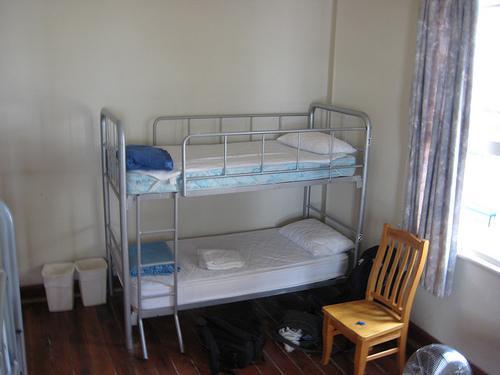How many trash cans are there?
Give a very brief answer. 2. How many beds are there?
Give a very brief answer. 2. How many mattresses are shown?
Give a very brief answer. 2. How many ladders are in the shot?
Give a very brief answer. 1. 